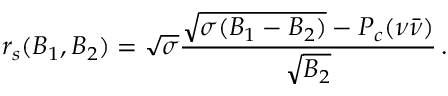Convert formula to latex. <formula><loc_0><loc_0><loc_500><loc_500>r _ { s } ( B _ { 1 } , B _ { 2 } ) = \sqrt { \sigma } { \frac { \sqrt { \sigma ( B _ { 1 } - B _ { 2 } ) } - P _ { c } ( \nu \bar { \nu } ) } { \sqrt { B _ { 2 } } } } \, .</formula> 